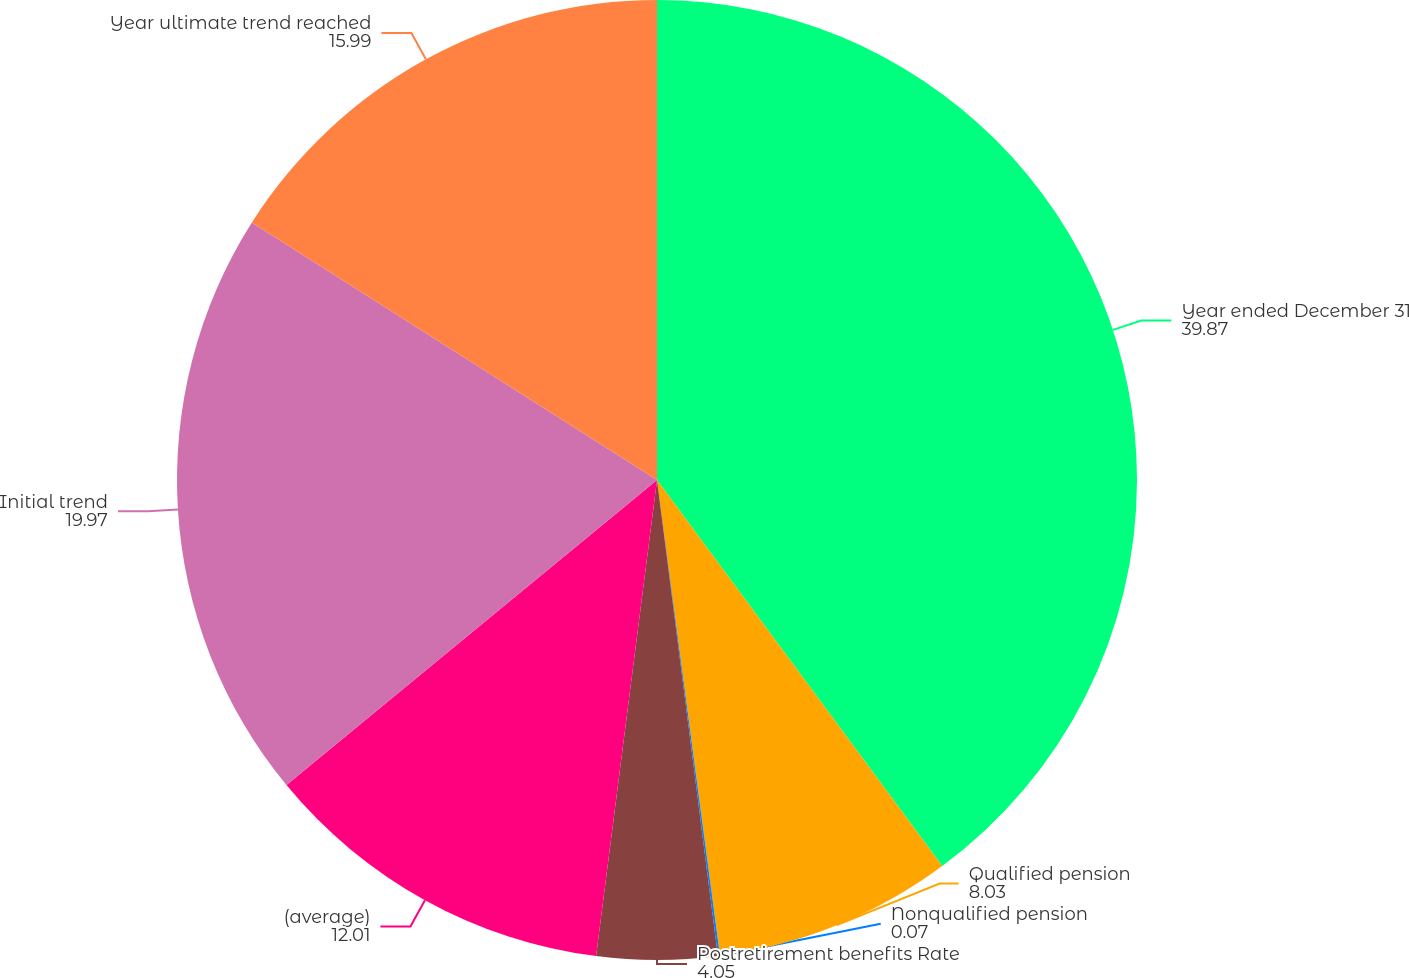Convert chart. <chart><loc_0><loc_0><loc_500><loc_500><pie_chart><fcel>Year ended December 31<fcel>Qualified pension<fcel>Nonqualified pension<fcel>Postretirement benefits Rate<fcel>(average)<fcel>Initial trend<fcel>Year ultimate trend reached<nl><fcel>39.87%<fcel>8.03%<fcel>0.07%<fcel>4.05%<fcel>12.01%<fcel>19.97%<fcel>15.99%<nl></chart> 